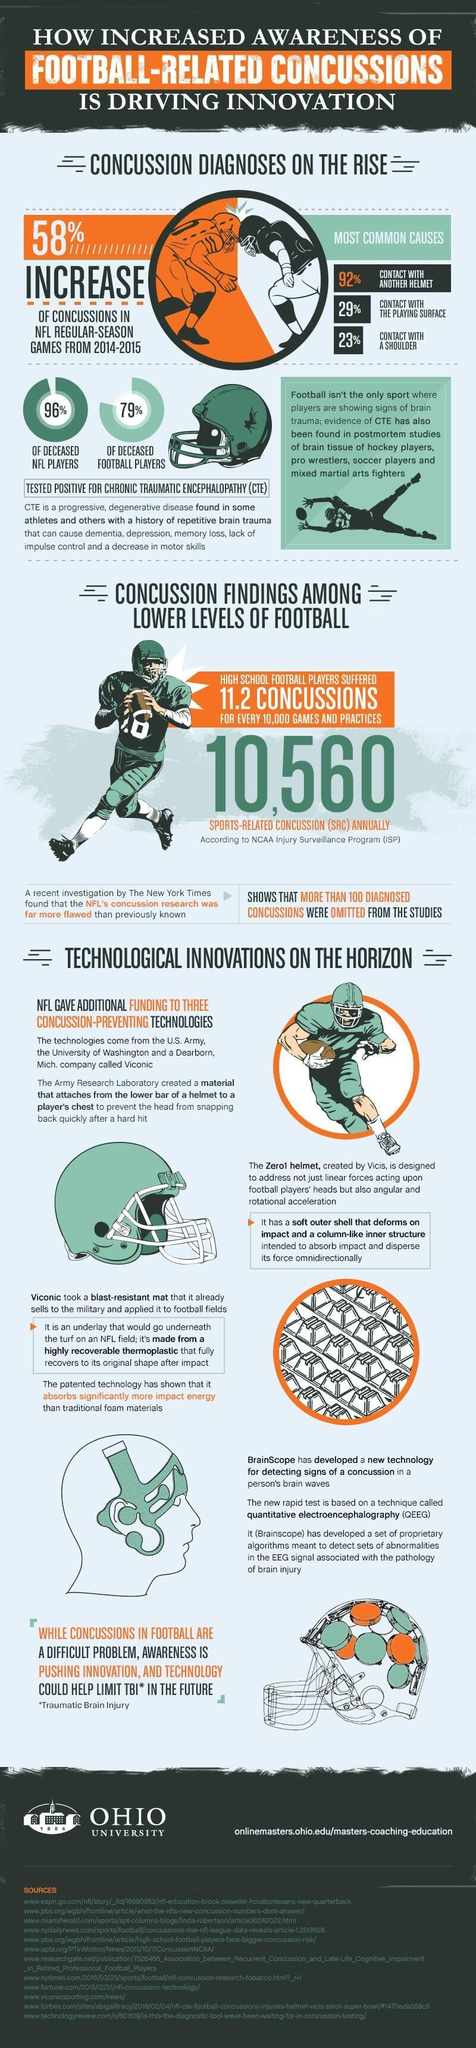Dementia, depression, memory loss, reduced motor skills are all symptoms of which condition?
Answer the question with a short phrase. CTE What type of technologies were developed by US Army, Washington University and Viconic? Concussion-preventing Technologies Whose findings exposed the flaws in NFL's concussion research? The New York Times How many of the deceased football players tested positive for CTE? 79% What was tested positive in 96% of deceased NFL players? Chronic Traumatic Encephalopathy (CTE) What was found in postmortem studies of hockey & soccer players, wrestlers & martial arts fighters? evidence of CTE How many concussions were found to be omitted from the NFL's concussion research studies? more than 100 What is the most common cause of concussion in football games? contact with another helmet What is the cause of CTE in athletes? repetitive brain trauma By what percentage did number of concussions in NFL games increase? 58% 